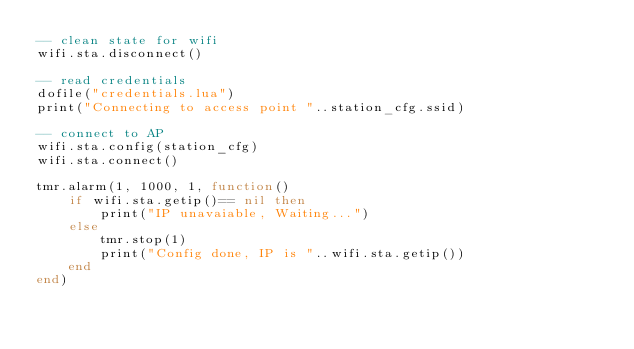Convert code to text. <code><loc_0><loc_0><loc_500><loc_500><_Lua_>-- clean state for wifi
wifi.sta.disconnect()

-- read credentials
dofile("credentials.lua")
print("Connecting to access point "..station_cfg.ssid)

-- connect to AP
wifi.sta.config(station_cfg)
wifi.sta.connect()

tmr.alarm(1, 1000, 1, function() 
    if wifi.sta.getip()== nil then 
        print("IP unavaiable, Waiting...") 
    else 
        tmr.stop(1)
        print("Config done, IP is "..wifi.sta.getip())
    end 
end)</code> 